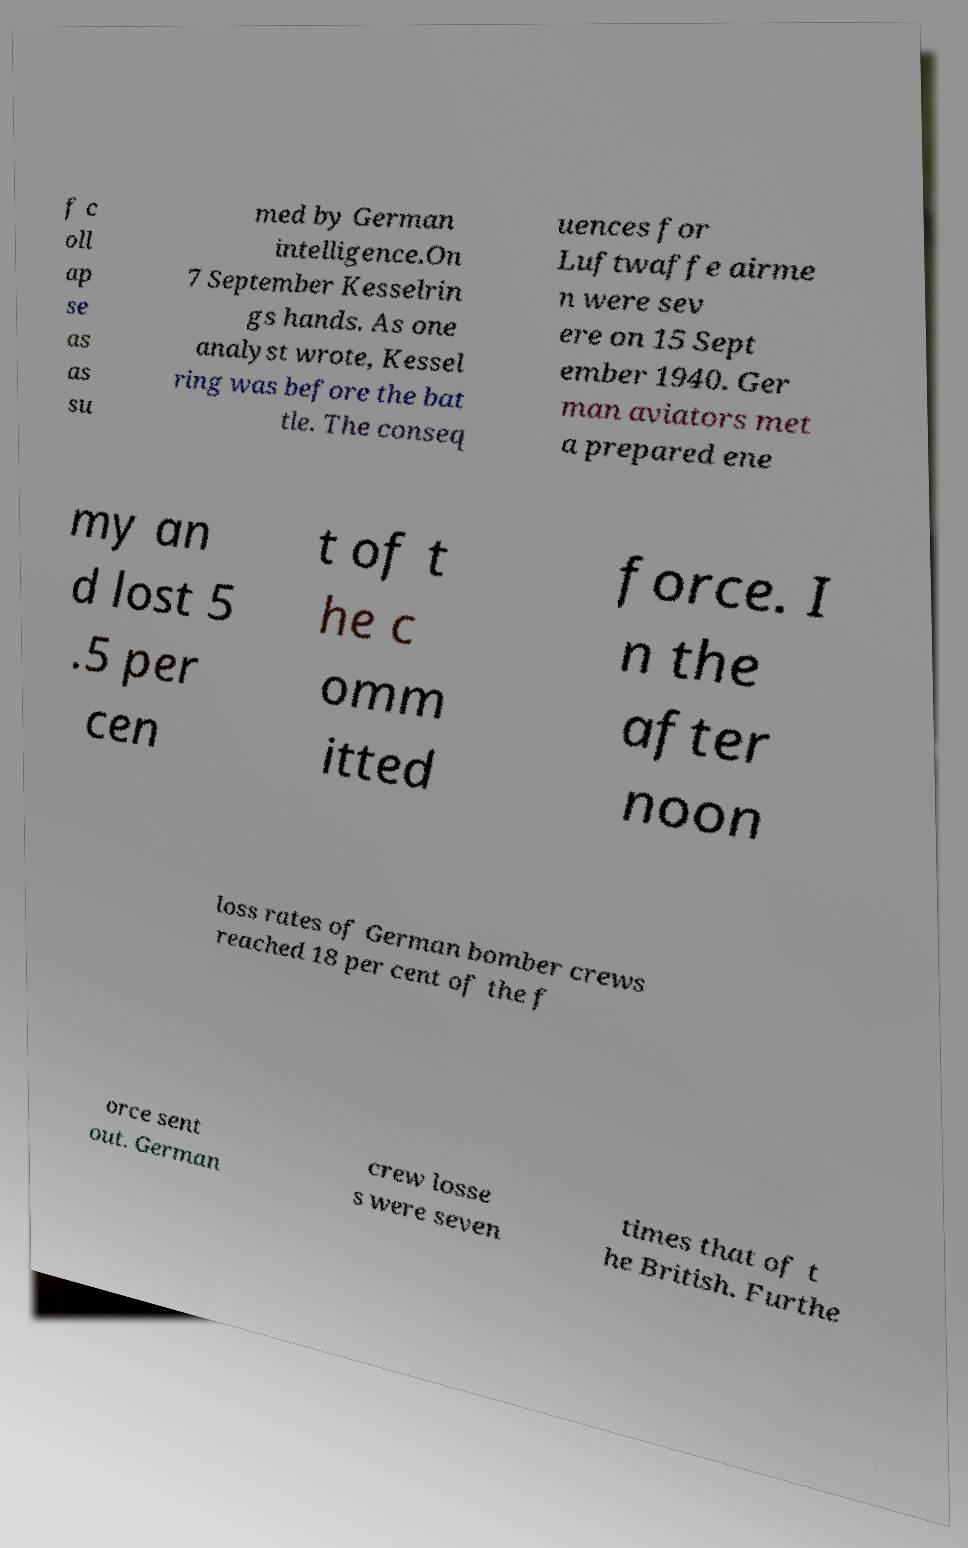Can you read and provide the text displayed in the image?This photo seems to have some interesting text. Can you extract and type it out for me? f c oll ap se as as su med by German intelligence.On 7 September Kesselrin gs hands. As one analyst wrote, Kessel ring was before the bat tle. The conseq uences for Luftwaffe airme n were sev ere on 15 Sept ember 1940. Ger man aviators met a prepared ene my an d lost 5 .5 per cen t of t he c omm itted force. I n the after noon loss rates of German bomber crews reached 18 per cent of the f orce sent out. German crew losse s were seven times that of t he British. Furthe 